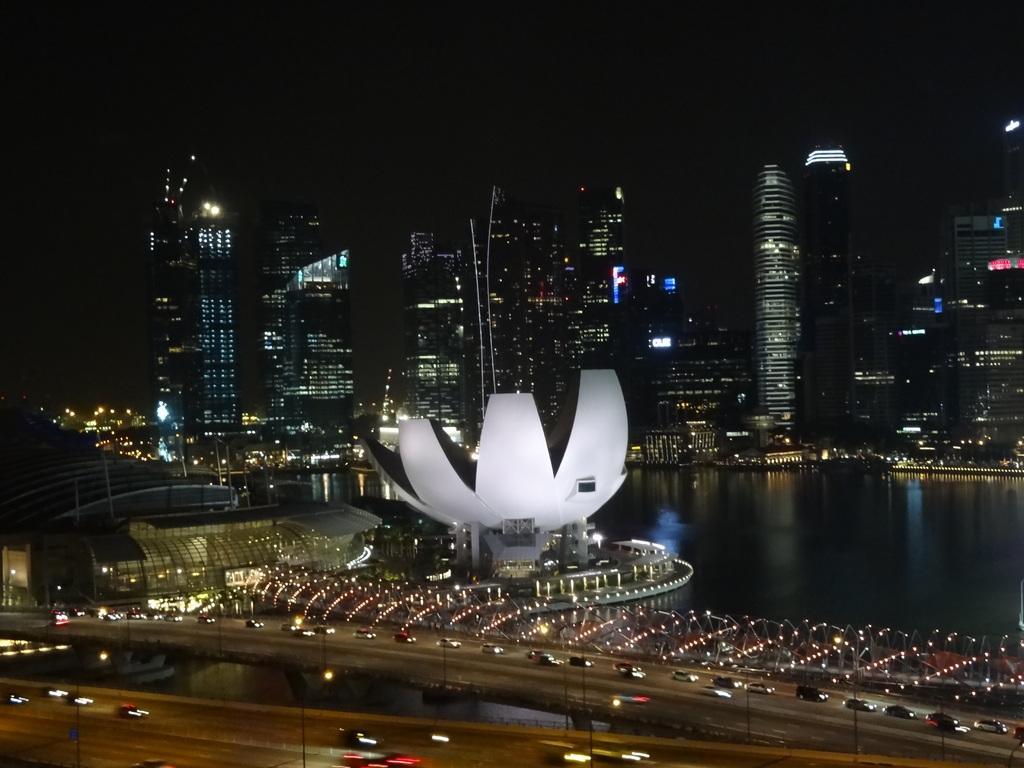Can you describe this image briefly? In this image we can see a bridge. On the bridge there are group of vehicles. Behind the bridge we can see water and buildings. In the buildings there are many lights. On top of the bridge we can see the lights. The background of the image is dark. 